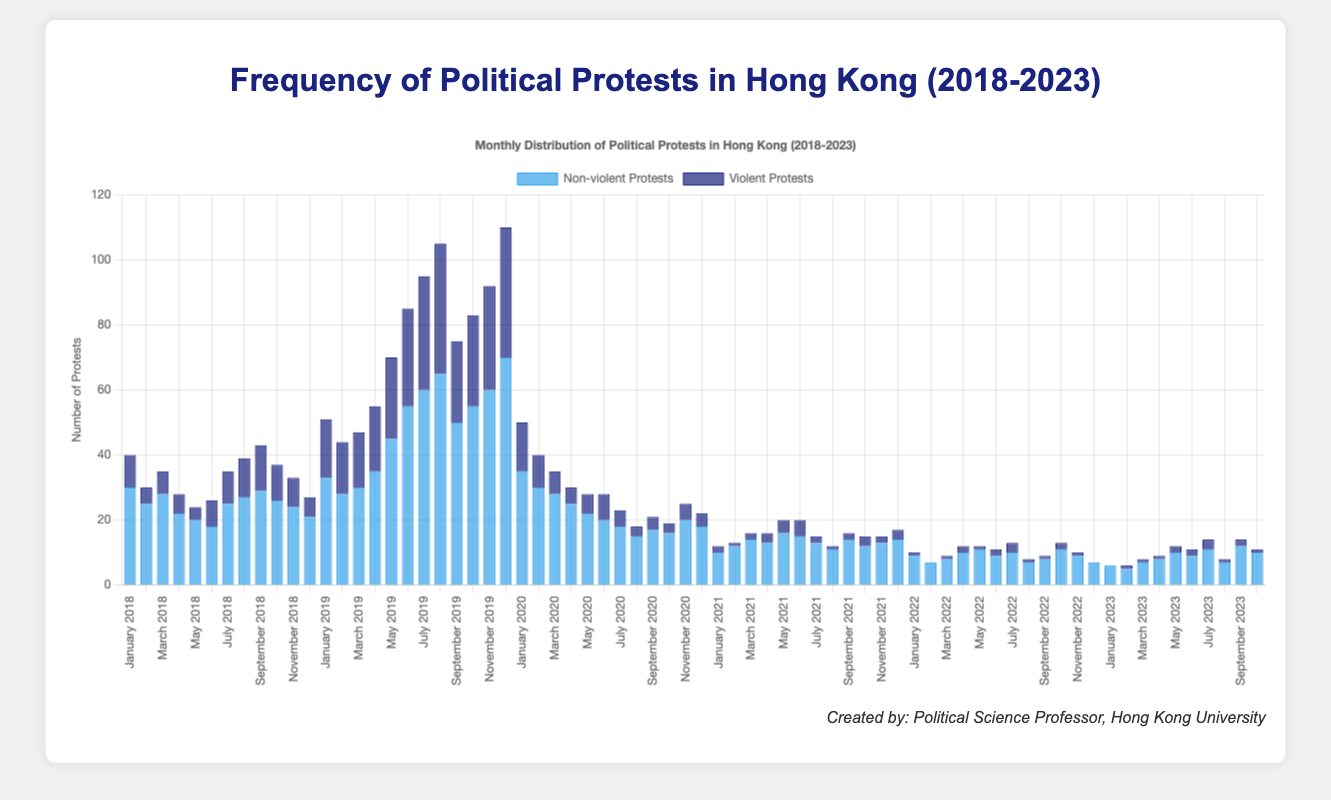What is the total number of non-violent and violent protests in 2019? Sum the non-violent protests for each month in 2019: (33 + 28 + 30 + 35 + 45 + 55 + 60 + 65 + 50 + 55 + 60 + 70) = 586. Sum the violent protests for the same year: (18 + 16 + 17 + 20 + 25 + 30 + 35 + 40 + 25 + 28 + 32 + 40) = 326. Add both sums: 586 + 326 = 912.
Answer: 912 Which year had the highest peak in political protests during a single month? The chart shows the highest bar in December 2019, indicating this is the month with the most protests in any year. Examining the year reveals that 2019 has the highest peak.
Answer: 2019 During which month did the number of violent protests remain constant for three consecutive years? Compare the bars for violent protests across years for constancy. The month of November had 9 violent protests in 2018, 32 in 2019, 5 in 2020, 2 in 2021, 1 in 2022, and 2 in 2023. Notice that the data doesn't show constancy in any consecutive years.
Answer: No month Which month witnessed the highest increase in non-violent protests from 2018 to 2019? From the chart, compare the changes from 2018 to 2019 for each month. May saw the highest increase—20 (2018) to 45 (2019), an increase of 25.
Answer: May What is the difference in the total number of non-violent protests between the years 2019 and 2020? Sum the non-violent protests for 2019: 586. Sum the non-violent protests for 2020: (35 + 30 + 28 + 25 + 22 + 20 + 18 + 15 + 17 + 16 + 20 + 18) = 264. Difference: 586 - 264 = 322.
Answer: 322 